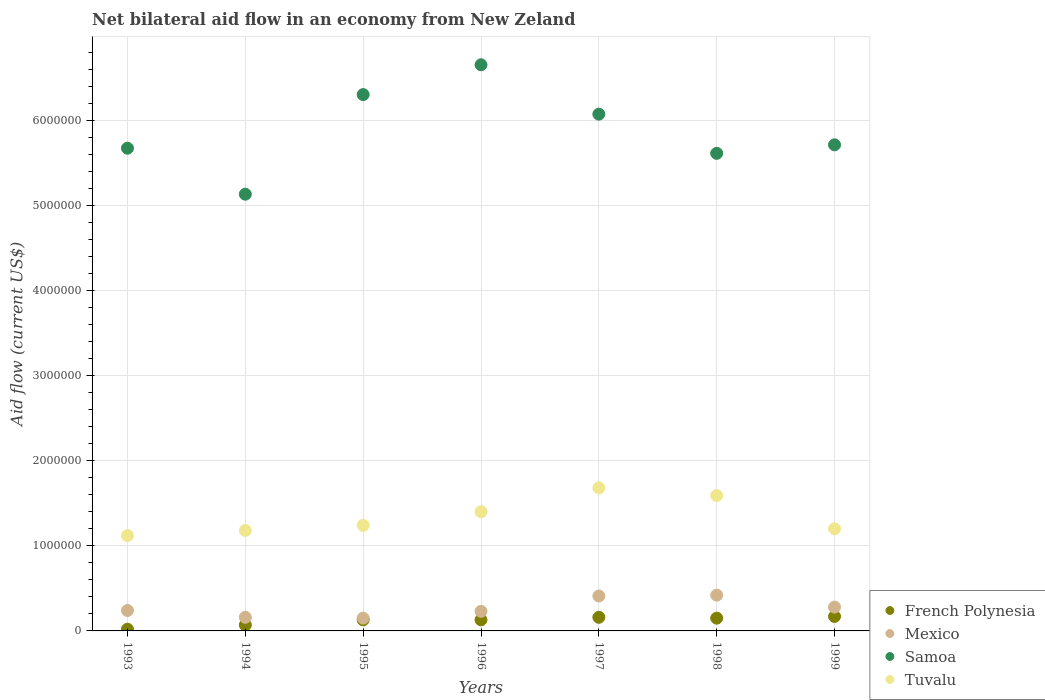Is the number of dotlines equal to the number of legend labels?
Offer a terse response. Yes. Across all years, what is the minimum net bilateral aid flow in Tuvalu?
Your answer should be very brief. 1.12e+06. In which year was the net bilateral aid flow in French Polynesia maximum?
Provide a short and direct response. 1999. What is the total net bilateral aid flow in French Polynesia in the graph?
Your response must be concise. 8.30e+05. What is the difference between the net bilateral aid flow in Tuvalu in 1993 and that in 1998?
Provide a short and direct response. -4.70e+05. What is the difference between the net bilateral aid flow in Samoa in 1993 and the net bilateral aid flow in French Polynesia in 1994?
Your answer should be very brief. 5.60e+06. What is the average net bilateral aid flow in French Polynesia per year?
Offer a terse response. 1.19e+05. In the year 1994, what is the difference between the net bilateral aid flow in French Polynesia and net bilateral aid flow in Tuvalu?
Keep it short and to the point. -1.11e+06. In how many years, is the net bilateral aid flow in Samoa greater than 5000000 US$?
Ensure brevity in your answer.  7. What is the ratio of the net bilateral aid flow in Mexico in 1994 to that in 1997?
Provide a short and direct response. 0.39. What is the difference between the highest and the lowest net bilateral aid flow in French Polynesia?
Provide a short and direct response. 1.50e+05. Is the sum of the net bilateral aid flow in Samoa in 1993 and 1994 greater than the maximum net bilateral aid flow in Mexico across all years?
Ensure brevity in your answer.  Yes. Is the net bilateral aid flow in Tuvalu strictly greater than the net bilateral aid flow in Mexico over the years?
Provide a succinct answer. Yes. Is the net bilateral aid flow in French Polynesia strictly less than the net bilateral aid flow in Samoa over the years?
Your answer should be compact. Yes. How many dotlines are there?
Give a very brief answer. 4. How many years are there in the graph?
Make the answer very short. 7. What is the difference between two consecutive major ticks on the Y-axis?
Your response must be concise. 1.00e+06. Where does the legend appear in the graph?
Ensure brevity in your answer.  Bottom right. How many legend labels are there?
Make the answer very short. 4. How are the legend labels stacked?
Offer a very short reply. Vertical. What is the title of the graph?
Ensure brevity in your answer.  Net bilateral aid flow in an economy from New Zeland. Does "Mauritania" appear as one of the legend labels in the graph?
Keep it short and to the point. No. What is the Aid flow (current US$) in Samoa in 1993?
Offer a terse response. 5.67e+06. What is the Aid flow (current US$) of Tuvalu in 1993?
Offer a terse response. 1.12e+06. What is the Aid flow (current US$) in Mexico in 1994?
Ensure brevity in your answer.  1.60e+05. What is the Aid flow (current US$) of Samoa in 1994?
Offer a terse response. 5.13e+06. What is the Aid flow (current US$) of Tuvalu in 1994?
Make the answer very short. 1.18e+06. What is the Aid flow (current US$) in Mexico in 1995?
Make the answer very short. 1.50e+05. What is the Aid flow (current US$) of Samoa in 1995?
Keep it short and to the point. 6.30e+06. What is the Aid flow (current US$) in Tuvalu in 1995?
Offer a very short reply. 1.24e+06. What is the Aid flow (current US$) of Mexico in 1996?
Provide a succinct answer. 2.30e+05. What is the Aid flow (current US$) in Samoa in 1996?
Your response must be concise. 6.65e+06. What is the Aid flow (current US$) of Tuvalu in 1996?
Keep it short and to the point. 1.40e+06. What is the Aid flow (current US$) of Samoa in 1997?
Your answer should be very brief. 6.07e+06. What is the Aid flow (current US$) in Tuvalu in 1997?
Your answer should be very brief. 1.68e+06. What is the Aid flow (current US$) of French Polynesia in 1998?
Keep it short and to the point. 1.50e+05. What is the Aid flow (current US$) in Samoa in 1998?
Make the answer very short. 5.61e+06. What is the Aid flow (current US$) of Tuvalu in 1998?
Your answer should be compact. 1.59e+06. What is the Aid flow (current US$) in French Polynesia in 1999?
Give a very brief answer. 1.70e+05. What is the Aid flow (current US$) of Mexico in 1999?
Offer a very short reply. 2.80e+05. What is the Aid flow (current US$) in Samoa in 1999?
Ensure brevity in your answer.  5.71e+06. What is the Aid flow (current US$) in Tuvalu in 1999?
Provide a short and direct response. 1.20e+06. Across all years, what is the maximum Aid flow (current US$) in French Polynesia?
Make the answer very short. 1.70e+05. Across all years, what is the maximum Aid flow (current US$) in Mexico?
Give a very brief answer. 4.20e+05. Across all years, what is the maximum Aid flow (current US$) in Samoa?
Make the answer very short. 6.65e+06. Across all years, what is the maximum Aid flow (current US$) in Tuvalu?
Offer a very short reply. 1.68e+06. Across all years, what is the minimum Aid flow (current US$) of Samoa?
Provide a short and direct response. 5.13e+06. Across all years, what is the minimum Aid flow (current US$) in Tuvalu?
Keep it short and to the point. 1.12e+06. What is the total Aid flow (current US$) in French Polynesia in the graph?
Offer a terse response. 8.30e+05. What is the total Aid flow (current US$) of Mexico in the graph?
Ensure brevity in your answer.  1.89e+06. What is the total Aid flow (current US$) of Samoa in the graph?
Offer a terse response. 4.11e+07. What is the total Aid flow (current US$) in Tuvalu in the graph?
Ensure brevity in your answer.  9.41e+06. What is the difference between the Aid flow (current US$) in French Polynesia in 1993 and that in 1994?
Give a very brief answer. -5.00e+04. What is the difference between the Aid flow (current US$) in Mexico in 1993 and that in 1994?
Provide a short and direct response. 8.00e+04. What is the difference between the Aid flow (current US$) in Samoa in 1993 and that in 1994?
Your answer should be very brief. 5.40e+05. What is the difference between the Aid flow (current US$) in Tuvalu in 1993 and that in 1994?
Ensure brevity in your answer.  -6.00e+04. What is the difference between the Aid flow (current US$) of Samoa in 1993 and that in 1995?
Your response must be concise. -6.30e+05. What is the difference between the Aid flow (current US$) of French Polynesia in 1993 and that in 1996?
Give a very brief answer. -1.10e+05. What is the difference between the Aid flow (current US$) of Samoa in 1993 and that in 1996?
Offer a terse response. -9.80e+05. What is the difference between the Aid flow (current US$) in Tuvalu in 1993 and that in 1996?
Offer a very short reply. -2.80e+05. What is the difference between the Aid flow (current US$) in French Polynesia in 1993 and that in 1997?
Offer a very short reply. -1.40e+05. What is the difference between the Aid flow (current US$) in Samoa in 1993 and that in 1997?
Give a very brief answer. -4.00e+05. What is the difference between the Aid flow (current US$) in Tuvalu in 1993 and that in 1997?
Offer a very short reply. -5.60e+05. What is the difference between the Aid flow (current US$) in French Polynesia in 1993 and that in 1998?
Give a very brief answer. -1.30e+05. What is the difference between the Aid flow (current US$) of Tuvalu in 1993 and that in 1998?
Give a very brief answer. -4.70e+05. What is the difference between the Aid flow (current US$) in French Polynesia in 1993 and that in 1999?
Your answer should be compact. -1.50e+05. What is the difference between the Aid flow (current US$) of Mexico in 1993 and that in 1999?
Offer a terse response. -4.00e+04. What is the difference between the Aid flow (current US$) in Samoa in 1993 and that in 1999?
Offer a very short reply. -4.00e+04. What is the difference between the Aid flow (current US$) in Tuvalu in 1993 and that in 1999?
Make the answer very short. -8.00e+04. What is the difference between the Aid flow (current US$) of Mexico in 1994 and that in 1995?
Offer a terse response. 10000. What is the difference between the Aid flow (current US$) in Samoa in 1994 and that in 1995?
Your answer should be compact. -1.17e+06. What is the difference between the Aid flow (current US$) of Samoa in 1994 and that in 1996?
Your answer should be compact. -1.52e+06. What is the difference between the Aid flow (current US$) in Mexico in 1994 and that in 1997?
Offer a terse response. -2.50e+05. What is the difference between the Aid flow (current US$) in Samoa in 1994 and that in 1997?
Offer a terse response. -9.40e+05. What is the difference between the Aid flow (current US$) of Tuvalu in 1994 and that in 1997?
Your response must be concise. -5.00e+05. What is the difference between the Aid flow (current US$) in French Polynesia in 1994 and that in 1998?
Keep it short and to the point. -8.00e+04. What is the difference between the Aid flow (current US$) of Mexico in 1994 and that in 1998?
Offer a very short reply. -2.60e+05. What is the difference between the Aid flow (current US$) of Samoa in 1994 and that in 1998?
Offer a very short reply. -4.80e+05. What is the difference between the Aid flow (current US$) in Tuvalu in 1994 and that in 1998?
Your answer should be compact. -4.10e+05. What is the difference between the Aid flow (current US$) of French Polynesia in 1994 and that in 1999?
Keep it short and to the point. -1.00e+05. What is the difference between the Aid flow (current US$) in Samoa in 1994 and that in 1999?
Your response must be concise. -5.80e+05. What is the difference between the Aid flow (current US$) in Mexico in 1995 and that in 1996?
Your answer should be very brief. -8.00e+04. What is the difference between the Aid flow (current US$) in Samoa in 1995 and that in 1996?
Give a very brief answer. -3.50e+05. What is the difference between the Aid flow (current US$) of Tuvalu in 1995 and that in 1996?
Your response must be concise. -1.60e+05. What is the difference between the Aid flow (current US$) of French Polynesia in 1995 and that in 1997?
Ensure brevity in your answer.  -3.00e+04. What is the difference between the Aid flow (current US$) in Mexico in 1995 and that in 1997?
Your answer should be very brief. -2.60e+05. What is the difference between the Aid flow (current US$) in Samoa in 1995 and that in 1997?
Make the answer very short. 2.30e+05. What is the difference between the Aid flow (current US$) in Tuvalu in 1995 and that in 1997?
Offer a terse response. -4.40e+05. What is the difference between the Aid flow (current US$) of Mexico in 1995 and that in 1998?
Offer a terse response. -2.70e+05. What is the difference between the Aid flow (current US$) of Samoa in 1995 and that in 1998?
Your response must be concise. 6.90e+05. What is the difference between the Aid flow (current US$) of Tuvalu in 1995 and that in 1998?
Ensure brevity in your answer.  -3.50e+05. What is the difference between the Aid flow (current US$) in Samoa in 1995 and that in 1999?
Provide a succinct answer. 5.90e+05. What is the difference between the Aid flow (current US$) of French Polynesia in 1996 and that in 1997?
Ensure brevity in your answer.  -3.00e+04. What is the difference between the Aid flow (current US$) of Samoa in 1996 and that in 1997?
Make the answer very short. 5.80e+05. What is the difference between the Aid flow (current US$) in Tuvalu in 1996 and that in 1997?
Your answer should be very brief. -2.80e+05. What is the difference between the Aid flow (current US$) of Mexico in 1996 and that in 1998?
Your answer should be very brief. -1.90e+05. What is the difference between the Aid flow (current US$) of Samoa in 1996 and that in 1998?
Keep it short and to the point. 1.04e+06. What is the difference between the Aid flow (current US$) of Tuvalu in 1996 and that in 1998?
Offer a terse response. -1.90e+05. What is the difference between the Aid flow (current US$) in French Polynesia in 1996 and that in 1999?
Provide a short and direct response. -4.00e+04. What is the difference between the Aid flow (current US$) of Samoa in 1996 and that in 1999?
Make the answer very short. 9.40e+05. What is the difference between the Aid flow (current US$) in Tuvalu in 1996 and that in 1999?
Offer a terse response. 2.00e+05. What is the difference between the Aid flow (current US$) of French Polynesia in 1997 and that in 1998?
Ensure brevity in your answer.  10000. What is the difference between the Aid flow (current US$) of Mexico in 1997 and that in 1998?
Keep it short and to the point. -10000. What is the difference between the Aid flow (current US$) of Samoa in 1997 and that in 1998?
Provide a short and direct response. 4.60e+05. What is the difference between the Aid flow (current US$) in Tuvalu in 1997 and that in 1998?
Offer a very short reply. 9.00e+04. What is the difference between the Aid flow (current US$) in French Polynesia in 1997 and that in 1999?
Offer a very short reply. -10000. What is the difference between the Aid flow (current US$) in Tuvalu in 1997 and that in 1999?
Make the answer very short. 4.80e+05. What is the difference between the Aid flow (current US$) of French Polynesia in 1998 and that in 1999?
Your response must be concise. -2.00e+04. What is the difference between the Aid flow (current US$) in Samoa in 1998 and that in 1999?
Provide a succinct answer. -1.00e+05. What is the difference between the Aid flow (current US$) in Tuvalu in 1998 and that in 1999?
Your answer should be very brief. 3.90e+05. What is the difference between the Aid flow (current US$) in French Polynesia in 1993 and the Aid flow (current US$) in Samoa in 1994?
Ensure brevity in your answer.  -5.11e+06. What is the difference between the Aid flow (current US$) in French Polynesia in 1993 and the Aid flow (current US$) in Tuvalu in 1994?
Provide a short and direct response. -1.16e+06. What is the difference between the Aid flow (current US$) of Mexico in 1993 and the Aid flow (current US$) of Samoa in 1994?
Provide a succinct answer. -4.89e+06. What is the difference between the Aid flow (current US$) in Mexico in 1993 and the Aid flow (current US$) in Tuvalu in 1994?
Provide a short and direct response. -9.40e+05. What is the difference between the Aid flow (current US$) in Samoa in 1993 and the Aid flow (current US$) in Tuvalu in 1994?
Provide a succinct answer. 4.49e+06. What is the difference between the Aid flow (current US$) in French Polynesia in 1993 and the Aid flow (current US$) in Samoa in 1995?
Your response must be concise. -6.28e+06. What is the difference between the Aid flow (current US$) of French Polynesia in 1993 and the Aid flow (current US$) of Tuvalu in 1995?
Provide a succinct answer. -1.22e+06. What is the difference between the Aid flow (current US$) in Mexico in 1993 and the Aid flow (current US$) in Samoa in 1995?
Make the answer very short. -6.06e+06. What is the difference between the Aid flow (current US$) in Samoa in 1993 and the Aid flow (current US$) in Tuvalu in 1995?
Your answer should be compact. 4.43e+06. What is the difference between the Aid flow (current US$) of French Polynesia in 1993 and the Aid flow (current US$) of Mexico in 1996?
Your answer should be compact. -2.10e+05. What is the difference between the Aid flow (current US$) in French Polynesia in 1993 and the Aid flow (current US$) in Samoa in 1996?
Offer a terse response. -6.63e+06. What is the difference between the Aid flow (current US$) in French Polynesia in 1993 and the Aid flow (current US$) in Tuvalu in 1996?
Offer a terse response. -1.38e+06. What is the difference between the Aid flow (current US$) in Mexico in 1993 and the Aid flow (current US$) in Samoa in 1996?
Your answer should be very brief. -6.41e+06. What is the difference between the Aid flow (current US$) of Mexico in 1993 and the Aid flow (current US$) of Tuvalu in 1996?
Offer a very short reply. -1.16e+06. What is the difference between the Aid flow (current US$) in Samoa in 1993 and the Aid flow (current US$) in Tuvalu in 1996?
Your answer should be very brief. 4.27e+06. What is the difference between the Aid flow (current US$) of French Polynesia in 1993 and the Aid flow (current US$) of Mexico in 1997?
Provide a succinct answer. -3.90e+05. What is the difference between the Aid flow (current US$) in French Polynesia in 1993 and the Aid flow (current US$) in Samoa in 1997?
Your answer should be compact. -6.05e+06. What is the difference between the Aid flow (current US$) in French Polynesia in 1993 and the Aid flow (current US$) in Tuvalu in 1997?
Provide a short and direct response. -1.66e+06. What is the difference between the Aid flow (current US$) of Mexico in 1993 and the Aid flow (current US$) of Samoa in 1997?
Keep it short and to the point. -5.83e+06. What is the difference between the Aid flow (current US$) of Mexico in 1993 and the Aid flow (current US$) of Tuvalu in 1997?
Provide a short and direct response. -1.44e+06. What is the difference between the Aid flow (current US$) of Samoa in 1993 and the Aid flow (current US$) of Tuvalu in 1997?
Provide a short and direct response. 3.99e+06. What is the difference between the Aid flow (current US$) in French Polynesia in 1993 and the Aid flow (current US$) in Mexico in 1998?
Provide a succinct answer. -4.00e+05. What is the difference between the Aid flow (current US$) in French Polynesia in 1993 and the Aid flow (current US$) in Samoa in 1998?
Your response must be concise. -5.59e+06. What is the difference between the Aid flow (current US$) in French Polynesia in 1993 and the Aid flow (current US$) in Tuvalu in 1998?
Provide a succinct answer. -1.57e+06. What is the difference between the Aid flow (current US$) of Mexico in 1993 and the Aid flow (current US$) of Samoa in 1998?
Provide a short and direct response. -5.37e+06. What is the difference between the Aid flow (current US$) in Mexico in 1993 and the Aid flow (current US$) in Tuvalu in 1998?
Make the answer very short. -1.35e+06. What is the difference between the Aid flow (current US$) of Samoa in 1993 and the Aid flow (current US$) of Tuvalu in 1998?
Keep it short and to the point. 4.08e+06. What is the difference between the Aid flow (current US$) in French Polynesia in 1993 and the Aid flow (current US$) in Mexico in 1999?
Offer a terse response. -2.60e+05. What is the difference between the Aid flow (current US$) in French Polynesia in 1993 and the Aid flow (current US$) in Samoa in 1999?
Keep it short and to the point. -5.69e+06. What is the difference between the Aid flow (current US$) in French Polynesia in 1993 and the Aid flow (current US$) in Tuvalu in 1999?
Offer a very short reply. -1.18e+06. What is the difference between the Aid flow (current US$) in Mexico in 1993 and the Aid flow (current US$) in Samoa in 1999?
Give a very brief answer. -5.47e+06. What is the difference between the Aid flow (current US$) of Mexico in 1993 and the Aid flow (current US$) of Tuvalu in 1999?
Your response must be concise. -9.60e+05. What is the difference between the Aid flow (current US$) in Samoa in 1993 and the Aid flow (current US$) in Tuvalu in 1999?
Your answer should be very brief. 4.47e+06. What is the difference between the Aid flow (current US$) in French Polynesia in 1994 and the Aid flow (current US$) in Mexico in 1995?
Offer a terse response. -8.00e+04. What is the difference between the Aid flow (current US$) in French Polynesia in 1994 and the Aid flow (current US$) in Samoa in 1995?
Provide a short and direct response. -6.23e+06. What is the difference between the Aid flow (current US$) of French Polynesia in 1994 and the Aid flow (current US$) of Tuvalu in 1995?
Provide a short and direct response. -1.17e+06. What is the difference between the Aid flow (current US$) of Mexico in 1994 and the Aid flow (current US$) of Samoa in 1995?
Offer a very short reply. -6.14e+06. What is the difference between the Aid flow (current US$) in Mexico in 1994 and the Aid flow (current US$) in Tuvalu in 1995?
Give a very brief answer. -1.08e+06. What is the difference between the Aid flow (current US$) in Samoa in 1994 and the Aid flow (current US$) in Tuvalu in 1995?
Offer a terse response. 3.89e+06. What is the difference between the Aid flow (current US$) of French Polynesia in 1994 and the Aid flow (current US$) of Mexico in 1996?
Give a very brief answer. -1.60e+05. What is the difference between the Aid flow (current US$) of French Polynesia in 1994 and the Aid flow (current US$) of Samoa in 1996?
Keep it short and to the point. -6.58e+06. What is the difference between the Aid flow (current US$) in French Polynesia in 1994 and the Aid flow (current US$) in Tuvalu in 1996?
Make the answer very short. -1.33e+06. What is the difference between the Aid flow (current US$) of Mexico in 1994 and the Aid flow (current US$) of Samoa in 1996?
Offer a very short reply. -6.49e+06. What is the difference between the Aid flow (current US$) in Mexico in 1994 and the Aid flow (current US$) in Tuvalu in 1996?
Offer a very short reply. -1.24e+06. What is the difference between the Aid flow (current US$) of Samoa in 1994 and the Aid flow (current US$) of Tuvalu in 1996?
Offer a very short reply. 3.73e+06. What is the difference between the Aid flow (current US$) of French Polynesia in 1994 and the Aid flow (current US$) of Samoa in 1997?
Ensure brevity in your answer.  -6.00e+06. What is the difference between the Aid flow (current US$) in French Polynesia in 1994 and the Aid flow (current US$) in Tuvalu in 1997?
Your answer should be very brief. -1.61e+06. What is the difference between the Aid flow (current US$) in Mexico in 1994 and the Aid flow (current US$) in Samoa in 1997?
Your response must be concise. -5.91e+06. What is the difference between the Aid flow (current US$) of Mexico in 1994 and the Aid flow (current US$) of Tuvalu in 1997?
Offer a terse response. -1.52e+06. What is the difference between the Aid flow (current US$) in Samoa in 1994 and the Aid flow (current US$) in Tuvalu in 1997?
Your response must be concise. 3.45e+06. What is the difference between the Aid flow (current US$) of French Polynesia in 1994 and the Aid flow (current US$) of Mexico in 1998?
Your response must be concise. -3.50e+05. What is the difference between the Aid flow (current US$) of French Polynesia in 1994 and the Aid flow (current US$) of Samoa in 1998?
Give a very brief answer. -5.54e+06. What is the difference between the Aid flow (current US$) of French Polynesia in 1994 and the Aid flow (current US$) of Tuvalu in 1998?
Your answer should be compact. -1.52e+06. What is the difference between the Aid flow (current US$) of Mexico in 1994 and the Aid flow (current US$) of Samoa in 1998?
Offer a terse response. -5.45e+06. What is the difference between the Aid flow (current US$) in Mexico in 1994 and the Aid flow (current US$) in Tuvalu in 1998?
Keep it short and to the point. -1.43e+06. What is the difference between the Aid flow (current US$) in Samoa in 1994 and the Aid flow (current US$) in Tuvalu in 1998?
Keep it short and to the point. 3.54e+06. What is the difference between the Aid flow (current US$) of French Polynesia in 1994 and the Aid flow (current US$) of Samoa in 1999?
Your answer should be very brief. -5.64e+06. What is the difference between the Aid flow (current US$) in French Polynesia in 1994 and the Aid flow (current US$) in Tuvalu in 1999?
Provide a succinct answer. -1.13e+06. What is the difference between the Aid flow (current US$) in Mexico in 1994 and the Aid flow (current US$) in Samoa in 1999?
Provide a succinct answer. -5.55e+06. What is the difference between the Aid flow (current US$) in Mexico in 1994 and the Aid flow (current US$) in Tuvalu in 1999?
Your response must be concise. -1.04e+06. What is the difference between the Aid flow (current US$) in Samoa in 1994 and the Aid flow (current US$) in Tuvalu in 1999?
Offer a terse response. 3.93e+06. What is the difference between the Aid flow (current US$) of French Polynesia in 1995 and the Aid flow (current US$) of Mexico in 1996?
Provide a succinct answer. -1.00e+05. What is the difference between the Aid flow (current US$) of French Polynesia in 1995 and the Aid flow (current US$) of Samoa in 1996?
Offer a very short reply. -6.52e+06. What is the difference between the Aid flow (current US$) in French Polynesia in 1995 and the Aid flow (current US$) in Tuvalu in 1996?
Offer a very short reply. -1.27e+06. What is the difference between the Aid flow (current US$) of Mexico in 1995 and the Aid flow (current US$) of Samoa in 1996?
Provide a short and direct response. -6.50e+06. What is the difference between the Aid flow (current US$) in Mexico in 1995 and the Aid flow (current US$) in Tuvalu in 1996?
Make the answer very short. -1.25e+06. What is the difference between the Aid flow (current US$) in Samoa in 1995 and the Aid flow (current US$) in Tuvalu in 1996?
Your answer should be compact. 4.90e+06. What is the difference between the Aid flow (current US$) of French Polynesia in 1995 and the Aid flow (current US$) of Mexico in 1997?
Your answer should be compact. -2.80e+05. What is the difference between the Aid flow (current US$) of French Polynesia in 1995 and the Aid flow (current US$) of Samoa in 1997?
Give a very brief answer. -5.94e+06. What is the difference between the Aid flow (current US$) of French Polynesia in 1995 and the Aid flow (current US$) of Tuvalu in 1997?
Your answer should be very brief. -1.55e+06. What is the difference between the Aid flow (current US$) of Mexico in 1995 and the Aid flow (current US$) of Samoa in 1997?
Provide a succinct answer. -5.92e+06. What is the difference between the Aid flow (current US$) of Mexico in 1995 and the Aid flow (current US$) of Tuvalu in 1997?
Provide a succinct answer. -1.53e+06. What is the difference between the Aid flow (current US$) in Samoa in 1995 and the Aid flow (current US$) in Tuvalu in 1997?
Provide a succinct answer. 4.62e+06. What is the difference between the Aid flow (current US$) of French Polynesia in 1995 and the Aid flow (current US$) of Samoa in 1998?
Your answer should be very brief. -5.48e+06. What is the difference between the Aid flow (current US$) in French Polynesia in 1995 and the Aid flow (current US$) in Tuvalu in 1998?
Offer a terse response. -1.46e+06. What is the difference between the Aid flow (current US$) in Mexico in 1995 and the Aid flow (current US$) in Samoa in 1998?
Offer a terse response. -5.46e+06. What is the difference between the Aid flow (current US$) of Mexico in 1995 and the Aid flow (current US$) of Tuvalu in 1998?
Your answer should be compact. -1.44e+06. What is the difference between the Aid flow (current US$) of Samoa in 1995 and the Aid flow (current US$) of Tuvalu in 1998?
Make the answer very short. 4.71e+06. What is the difference between the Aid flow (current US$) in French Polynesia in 1995 and the Aid flow (current US$) in Mexico in 1999?
Make the answer very short. -1.50e+05. What is the difference between the Aid flow (current US$) in French Polynesia in 1995 and the Aid flow (current US$) in Samoa in 1999?
Ensure brevity in your answer.  -5.58e+06. What is the difference between the Aid flow (current US$) in French Polynesia in 1995 and the Aid flow (current US$) in Tuvalu in 1999?
Keep it short and to the point. -1.07e+06. What is the difference between the Aid flow (current US$) of Mexico in 1995 and the Aid flow (current US$) of Samoa in 1999?
Provide a succinct answer. -5.56e+06. What is the difference between the Aid flow (current US$) of Mexico in 1995 and the Aid flow (current US$) of Tuvalu in 1999?
Keep it short and to the point. -1.05e+06. What is the difference between the Aid flow (current US$) of Samoa in 1995 and the Aid flow (current US$) of Tuvalu in 1999?
Your response must be concise. 5.10e+06. What is the difference between the Aid flow (current US$) of French Polynesia in 1996 and the Aid flow (current US$) of Mexico in 1997?
Offer a terse response. -2.80e+05. What is the difference between the Aid flow (current US$) in French Polynesia in 1996 and the Aid flow (current US$) in Samoa in 1997?
Offer a very short reply. -5.94e+06. What is the difference between the Aid flow (current US$) of French Polynesia in 1996 and the Aid flow (current US$) of Tuvalu in 1997?
Offer a terse response. -1.55e+06. What is the difference between the Aid flow (current US$) in Mexico in 1996 and the Aid flow (current US$) in Samoa in 1997?
Provide a short and direct response. -5.84e+06. What is the difference between the Aid flow (current US$) in Mexico in 1996 and the Aid flow (current US$) in Tuvalu in 1997?
Your answer should be compact. -1.45e+06. What is the difference between the Aid flow (current US$) of Samoa in 1996 and the Aid flow (current US$) of Tuvalu in 1997?
Ensure brevity in your answer.  4.97e+06. What is the difference between the Aid flow (current US$) in French Polynesia in 1996 and the Aid flow (current US$) in Samoa in 1998?
Provide a succinct answer. -5.48e+06. What is the difference between the Aid flow (current US$) in French Polynesia in 1996 and the Aid flow (current US$) in Tuvalu in 1998?
Give a very brief answer. -1.46e+06. What is the difference between the Aid flow (current US$) of Mexico in 1996 and the Aid flow (current US$) of Samoa in 1998?
Offer a very short reply. -5.38e+06. What is the difference between the Aid flow (current US$) in Mexico in 1996 and the Aid flow (current US$) in Tuvalu in 1998?
Make the answer very short. -1.36e+06. What is the difference between the Aid flow (current US$) in Samoa in 1996 and the Aid flow (current US$) in Tuvalu in 1998?
Offer a terse response. 5.06e+06. What is the difference between the Aid flow (current US$) in French Polynesia in 1996 and the Aid flow (current US$) in Samoa in 1999?
Make the answer very short. -5.58e+06. What is the difference between the Aid flow (current US$) of French Polynesia in 1996 and the Aid flow (current US$) of Tuvalu in 1999?
Ensure brevity in your answer.  -1.07e+06. What is the difference between the Aid flow (current US$) in Mexico in 1996 and the Aid flow (current US$) in Samoa in 1999?
Provide a succinct answer. -5.48e+06. What is the difference between the Aid flow (current US$) in Mexico in 1996 and the Aid flow (current US$) in Tuvalu in 1999?
Offer a very short reply. -9.70e+05. What is the difference between the Aid flow (current US$) in Samoa in 1996 and the Aid flow (current US$) in Tuvalu in 1999?
Make the answer very short. 5.45e+06. What is the difference between the Aid flow (current US$) of French Polynesia in 1997 and the Aid flow (current US$) of Samoa in 1998?
Your answer should be compact. -5.45e+06. What is the difference between the Aid flow (current US$) of French Polynesia in 1997 and the Aid flow (current US$) of Tuvalu in 1998?
Make the answer very short. -1.43e+06. What is the difference between the Aid flow (current US$) of Mexico in 1997 and the Aid flow (current US$) of Samoa in 1998?
Keep it short and to the point. -5.20e+06. What is the difference between the Aid flow (current US$) in Mexico in 1997 and the Aid flow (current US$) in Tuvalu in 1998?
Give a very brief answer. -1.18e+06. What is the difference between the Aid flow (current US$) in Samoa in 1997 and the Aid flow (current US$) in Tuvalu in 1998?
Your answer should be compact. 4.48e+06. What is the difference between the Aid flow (current US$) in French Polynesia in 1997 and the Aid flow (current US$) in Mexico in 1999?
Offer a terse response. -1.20e+05. What is the difference between the Aid flow (current US$) in French Polynesia in 1997 and the Aid flow (current US$) in Samoa in 1999?
Offer a terse response. -5.55e+06. What is the difference between the Aid flow (current US$) of French Polynesia in 1997 and the Aid flow (current US$) of Tuvalu in 1999?
Make the answer very short. -1.04e+06. What is the difference between the Aid flow (current US$) of Mexico in 1997 and the Aid flow (current US$) of Samoa in 1999?
Make the answer very short. -5.30e+06. What is the difference between the Aid flow (current US$) in Mexico in 1997 and the Aid flow (current US$) in Tuvalu in 1999?
Ensure brevity in your answer.  -7.90e+05. What is the difference between the Aid flow (current US$) in Samoa in 1997 and the Aid flow (current US$) in Tuvalu in 1999?
Ensure brevity in your answer.  4.87e+06. What is the difference between the Aid flow (current US$) of French Polynesia in 1998 and the Aid flow (current US$) of Samoa in 1999?
Offer a terse response. -5.56e+06. What is the difference between the Aid flow (current US$) in French Polynesia in 1998 and the Aid flow (current US$) in Tuvalu in 1999?
Offer a very short reply. -1.05e+06. What is the difference between the Aid flow (current US$) of Mexico in 1998 and the Aid flow (current US$) of Samoa in 1999?
Provide a short and direct response. -5.29e+06. What is the difference between the Aid flow (current US$) in Mexico in 1998 and the Aid flow (current US$) in Tuvalu in 1999?
Give a very brief answer. -7.80e+05. What is the difference between the Aid flow (current US$) in Samoa in 1998 and the Aid flow (current US$) in Tuvalu in 1999?
Provide a succinct answer. 4.41e+06. What is the average Aid flow (current US$) in French Polynesia per year?
Offer a very short reply. 1.19e+05. What is the average Aid flow (current US$) of Samoa per year?
Offer a terse response. 5.88e+06. What is the average Aid flow (current US$) in Tuvalu per year?
Your response must be concise. 1.34e+06. In the year 1993, what is the difference between the Aid flow (current US$) of French Polynesia and Aid flow (current US$) of Samoa?
Provide a succinct answer. -5.65e+06. In the year 1993, what is the difference between the Aid flow (current US$) of French Polynesia and Aid flow (current US$) of Tuvalu?
Your answer should be compact. -1.10e+06. In the year 1993, what is the difference between the Aid flow (current US$) of Mexico and Aid flow (current US$) of Samoa?
Keep it short and to the point. -5.43e+06. In the year 1993, what is the difference between the Aid flow (current US$) of Mexico and Aid flow (current US$) of Tuvalu?
Keep it short and to the point. -8.80e+05. In the year 1993, what is the difference between the Aid flow (current US$) of Samoa and Aid flow (current US$) of Tuvalu?
Keep it short and to the point. 4.55e+06. In the year 1994, what is the difference between the Aid flow (current US$) in French Polynesia and Aid flow (current US$) in Samoa?
Provide a succinct answer. -5.06e+06. In the year 1994, what is the difference between the Aid flow (current US$) of French Polynesia and Aid flow (current US$) of Tuvalu?
Offer a terse response. -1.11e+06. In the year 1994, what is the difference between the Aid flow (current US$) in Mexico and Aid flow (current US$) in Samoa?
Make the answer very short. -4.97e+06. In the year 1994, what is the difference between the Aid flow (current US$) of Mexico and Aid flow (current US$) of Tuvalu?
Provide a short and direct response. -1.02e+06. In the year 1994, what is the difference between the Aid flow (current US$) in Samoa and Aid flow (current US$) in Tuvalu?
Give a very brief answer. 3.95e+06. In the year 1995, what is the difference between the Aid flow (current US$) in French Polynesia and Aid flow (current US$) in Samoa?
Give a very brief answer. -6.17e+06. In the year 1995, what is the difference between the Aid flow (current US$) of French Polynesia and Aid flow (current US$) of Tuvalu?
Offer a terse response. -1.11e+06. In the year 1995, what is the difference between the Aid flow (current US$) in Mexico and Aid flow (current US$) in Samoa?
Keep it short and to the point. -6.15e+06. In the year 1995, what is the difference between the Aid flow (current US$) of Mexico and Aid flow (current US$) of Tuvalu?
Provide a succinct answer. -1.09e+06. In the year 1995, what is the difference between the Aid flow (current US$) in Samoa and Aid flow (current US$) in Tuvalu?
Make the answer very short. 5.06e+06. In the year 1996, what is the difference between the Aid flow (current US$) of French Polynesia and Aid flow (current US$) of Samoa?
Ensure brevity in your answer.  -6.52e+06. In the year 1996, what is the difference between the Aid flow (current US$) of French Polynesia and Aid flow (current US$) of Tuvalu?
Keep it short and to the point. -1.27e+06. In the year 1996, what is the difference between the Aid flow (current US$) of Mexico and Aid flow (current US$) of Samoa?
Your answer should be very brief. -6.42e+06. In the year 1996, what is the difference between the Aid flow (current US$) in Mexico and Aid flow (current US$) in Tuvalu?
Your response must be concise. -1.17e+06. In the year 1996, what is the difference between the Aid flow (current US$) of Samoa and Aid flow (current US$) of Tuvalu?
Provide a short and direct response. 5.25e+06. In the year 1997, what is the difference between the Aid flow (current US$) in French Polynesia and Aid flow (current US$) in Samoa?
Your answer should be very brief. -5.91e+06. In the year 1997, what is the difference between the Aid flow (current US$) of French Polynesia and Aid flow (current US$) of Tuvalu?
Your response must be concise. -1.52e+06. In the year 1997, what is the difference between the Aid flow (current US$) of Mexico and Aid flow (current US$) of Samoa?
Keep it short and to the point. -5.66e+06. In the year 1997, what is the difference between the Aid flow (current US$) of Mexico and Aid flow (current US$) of Tuvalu?
Your answer should be compact. -1.27e+06. In the year 1997, what is the difference between the Aid flow (current US$) in Samoa and Aid flow (current US$) in Tuvalu?
Give a very brief answer. 4.39e+06. In the year 1998, what is the difference between the Aid flow (current US$) of French Polynesia and Aid flow (current US$) of Samoa?
Ensure brevity in your answer.  -5.46e+06. In the year 1998, what is the difference between the Aid flow (current US$) of French Polynesia and Aid flow (current US$) of Tuvalu?
Your answer should be very brief. -1.44e+06. In the year 1998, what is the difference between the Aid flow (current US$) in Mexico and Aid flow (current US$) in Samoa?
Give a very brief answer. -5.19e+06. In the year 1998, what is the difference between the Aid flow (current US$) of Mexico and Aid flow (current US$) of Tuvalu?
Make the answer very short. -1.17e+06. In the year 1998, what is the difference between the Aid flow (current US$) of Samoa and Aid flow (current US$) of Tuvalu?
Provide a succinct answer. 4.02e+06. In the year 1999, what is the difference between the Aid flow (current US$) in French Polynesia and Aid flow (current US$) in Samoa?
Make the answer very short. -5.54e+06. In the year 1999, what is the difference between the Aid flow (current US$) of French Polynesia and Aid flow (current US$) of Tuvalu?
Your response must be concise. -1.03e+06. In the year 1999, what is the difference between the Aid flow (current US$) of Mexico and Aid flow (current US$) of Samoa?
Your answer should be compact. -5.43e+06. In the year 1999, what is the difference between the Aid flow (current US$) in Mexico and Aid flow (current US$) in Tuvalu?
Your response must be concise. -9.20e+05. In the year 1999, what is the difference between the Aid flow (current US$) in Samoa and Aid flow (current US$) in Tuvalu?
Offer a very short reply. 4.51e+06. What is the ratio of the Aid flow (current US$) of French Polynesia in 1993 to that in 1994?
Your answer should be very brief. 0.29. What is the ratio of the Aid flow (current US$) in Mexico in 1993 to that in 1994?
Provide a succinct answer. 1.5. What is the ratio of the Aid flow (current US$) of Samoa in 1993 to that in 1994?
Your response must be concise. 1.11. What is the ratio of the Aid flow (current US$) of Tuvalu in 1993 to that in 1994?
Keep it short and to the point. 0.95. What is the ratio of the Aid flow (current US$) in French Polynesia in 1993 to that in 1995?
Provide a short and direct response. 0.15. What is the ratio of the Aid flow (current US$) of Mexico in 1993 to that in 1995?
Your answer should be very brief. 1.6. What is the ratio of the Aid flow (current US$) of Samoa in 1993 to that in 1995?
Provide a short and direct response. 0.9. What is the ratio of the Aid flow (current US$) of Tuvalu in 1993 to that in 1995?
Your response must be concise. 0.9. What is the ratio of the Aid flow (current US$) of French Polynesia in 1993 to that in 1996?
Your answer should be very brief. 0.15. What is the ratio of the Aid flow (current US$) in Mexico in 1993 to that in 1996?
Provide a succinct answer. 1.04. What is the ratio of the Aid flow (current US$) in Samoa in 1993 to that in 1996?
Make the answer very short. 0.85. What is the ratio of the Aid flow (current US$) of Tuvalu in 1993 to that in 1996?
Provide a short and direct response. 0.8. What is the ratio of the Aid flow (current US$) in Mexico in 1993 to that in 1997?
Your answer should be very brief. 0.59. What is the ratio of the Aid flow (current US$) in Samoa in 1993 to that in 1997?
Your answer should be very brief. 0.93. What is the ratio of the Aid flow (current US$) of Tuvalu in 1993 to that in 1997?
Keep it short and to the point. 0.67. What is the ratio of the Aid flow (current US$) of French Polynesia in 1993 to that in 1998?
Your answer should be very brief. 0.13. What is the ratio of the Aid flow (current US$) of Samoa in 1993 to that in 1998?
Keep it short and to the point. 1.01. What is the ratio of the Aid flow (current US$) in Tuvalu in 1993 to that in 1998?
Ensure brevity in your answer.  0.7. What is the ratio of the Aid flow (current US$) of French Polynesia in 1993 to that in 1999?
Make the answer very short. 0.12. What is the ratio of the Aid flow (current US$) in Samoa in 1993 to that in 1999?
Offer a very short reply. 0.99. What is the ratio of the Aid flow (current US$) of French Polynesia in 1994 to that in 1995?
Give a very brief answer. 0.54. What is the ratio of the Aid flow (current US$) in Mexico in 1994 to that in 1995?
Ensure brevity in your answer.  1.07. What is the ratio of the Aid flow (current US$) of Samoa in 1994 to that in 1995?
Ensure brevity in your answer.  0.81. What is the ratio of the Aid flow (current US$) of Tuvalu in 1994 to that in 1995?
Keep it short and to the point. 0.95. What is the ratio of the Aid flow (current US$) in French Polynesia in 1994 to that in 1996?
Offer a terse response. 0.54. What is the ratio of the Aid flow (current US$) of Mexico in 1994 to that in 1996?
Keep it short and to the point. 0.7. What is the ratio of the Aid flow (current US$) in Samoa in 1994 to that in 1996?
Provide a succinct answer. 0.77. What is the ratio of the Aid flow (current US$) in Tuvalu in 1994 to that in 1996?
Your answer should be compact. 0.84. What is the ratio of the Aid flow (current US$) in French Polynesia in 1994 to that in 1997?
Your answer should be very brief. 0.44. What is the ratio of the Aid flow (current US$) in Mexico in 1994 to that in 1997?
Your answer should be compact. 0.39. What is the ratio of the Aid flow (current US$) in Samoa in 1994 to that in 1997?
Provide a succinct answer. 0.85. What is the ratio of the Aid flow (current US$) of Tuvalu in 1994 to that in 1997?
Give a very brief answer. 0.7. What is the ratio of the Aid flow (current US$) of French Polynesia in 1994 to that in 1998?
Make the answer very short. 0.47. What is the ratio of the Aid flow (current US$) of Mexico in 1994 to that in 1998?
Your answer should be very brief. 0.38. What is the ratio of the Aid flow (current US$) of Samoa in 1994 to that in 1998?
Keep it short and to the point. 0.91. What is the ratio of the Aid flow (current US$) in Tuvalu in 1994 to that in 1998?
Make the answer very short. 0.74. What is the ratio of the Aid flow (current US$) of French Polynesia in 1994 to that in 1999?
Your answer should be compact. 0.41. What is the ratio of the Aid flow (current US$) in Mexico in 1994 to that in 1999?
Provide a short and direct response. 0.57. What is the ratio of the Aid flow (current US$) of Samoa in 1994 to that in 1999?
Ensure brevity in your answer.  0.9. What is the ratio of the Aid flow (current US$) of Tuvalu in 1994 to that in 1999?
Ensure brevity in your answer.  0.98. What is the ratio of the Aid flow (current US$) of Mexico in 1995 to that in 1996?
Make the answer very short. 0.65. What is the ratio of the Aid flow (current US$) of Tuvalu in 1995 to that in 1996?
Provide a succinct answer. 0.89. What is the ratio of the Aid flow (current US$) in French Polynesia in 1995 to that in 1997?
Your answer should be compact. 0.81. What is the ratio of the Aid flow (current US$) of Mexico in 1995 to that in 1997?
Ensure brevity in your answer.  0.37. What is the ratio of the Aid flow (current US$) of Samoa in 1995 to that in 1997?
Make the answer very short. 1.04. What is the ratio of the Aid flow (current US$) in Tuvalu in 1995 to that in 1997?
Give a very brief answer. 0.74. What is the ratio of the Aid flow (current US$) in French Polynesia in 1995 to that in 1998?
Provide a succinct answer. 0.87. What is the ratio of the Aid flow (current US$) in Mexico in 1995 to that in 1998?
Keep it short and to the point. 0.36. What is the ratio of the Aid flow (current US$) in Samoa in 1995 to that in 1998?
Your answer should be very brief. 1.12. What is the ratio of the Aid flow (current US$) of Tuvalu in 1995 to that in 1998?
Provide a succinct answer. 0.78. What is the ratio of the Aid flow (current US$) in French Polynesia in 1995 to that in 1999?
Keep it short and to the point. 0.76. What is the ratio of the Aid flow (current US$) of Mexico in 1995 to that in 1999?
Your answer should be compact. 0.54. What is the ratio of the Aid flow (current US$) in Samoa in 1995 to that in 1999?
Give a very brief answer. 1.1. What is the ratio of the Aid flow (current US$) of French Polynesia in 1996 to that in 1997?
Offer a very short reply. 0.81. What is the ratio of the Aid flow (current US$) in Mexico in 1996 to that in 1997?
Ensure brevity in your answer.  0.56. What is the ratio of the Aid flow (current US$) in Samoa in 1996 to that in 1997?
Provide a short and direct response. 1.1. What is the ratio of the Aid flow (current US$) of French Polynesia in 1996 to that in 1998?
Offer a very short reply. 0.87. What is the ratio of the Aid flow (current US$) in Mexico in 1996 to that in 1998?
Keep it short and to the point. 0.55. What is the ratio of the Aid flow (current US$) in Samoa in 1996 to that in 1998?
Provide a short and direct response. 1.19. What is the ratio of the Aid flow (current US$) of Tuvalu in 1996 to that in 1998?
Make the answer very short. 0.88. What is the ratio of the Aid flow (current US$) in French Polynesia in 1996 to that in 1999?
Keep it short and to the point. 0.76. What is the ratio of the Aid flow (current US$) in Mexico in 1996 to that in 1999?
Your response must be concise. 0.82. What is the ratio of the Aid flow (current US$) of Samoa in 1996 to that in 1999?
Make the answer very short. 1.16. What is the ratio of the Aid flow (current US$) of French Polynesia in 1997 to that in 1998?
Offer a terse response. 1.07. What is the ratio of the Aid flow (current US$) in Mexico in 1997 to that in 1998?
Give a very brief answer. 0.98. What is the ratio of the Aid flow (current US$) of Samoa in 1997 to that in 1998?
Provide a succinct answer. 1.08. What is the ratio of the Aid flow (current US$) of Tuvalu in 1997 to that in 1998?
Your answer should be very brief. 1.06. What is the ratio of the Aid flow (current US$) of French Polynesia in 1997 to that in 1999?
Offer a terse response. 0.94. What is the ratio of the Aid flow (current US$) of Mexico in 1997 to that in 1999?
Your answer should be compact. 1.46. What is the ratio of the Aid flow (current US$) in Samoa in 1997 to that in 1999?
Give a very brief answer. 1.06. What is the ratio of the Aid flow (current US$) of French Polynesia in 1998 to that in 1999?
Your response must be concise. 0.88. What is the ratio of the Aid flow (current US$) of Samoa in 1998 to that in 1999?
Your response must be concise. 0.98. What is the ratio of the Aid flow (current US$) in Tuvalu in 1998 to that in 1999?
Give a very brief answer. 1.32. What is the difference between the highest and the second highest Aid flow (current US$) of Mexico?
Give a very brief answer. 10000. What is the difference between the highest and the second highest Aid flow (current US$) of Samoa?
Give a very brief answer. 3.50e+05. What is the difference between the highest and the lowest Aid flow (current US$) of Mexico?
Keep it short and to the point. 2.70e+05. What is the difference between the highest and the lowest Aid flow (current US$) in Samoa?
Provide a succinct answer. 1.52e+06. What is the difference between the highest and the lowest Aid flow (current US$) of Tuvalu?
Your response must be concise. 5.60e+05. 